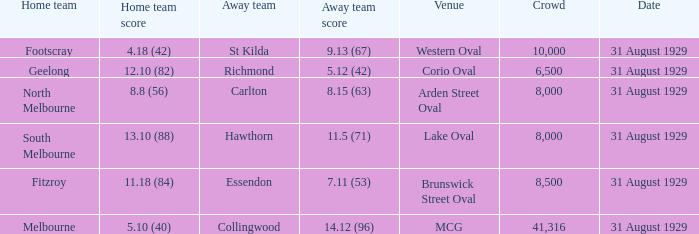What was the score of the home team when the away team scored 14.12 (96)? 5.10 (40). Help me parse the entirety of this table. {'header': ['Home team', 'Home team score', 'Away team', 'Away team score', 'Venue', 'Crowd', 'Date'], 'rows': [['Footscray', '4.18 (42)', 'St Kilda', '9.13 (67)', 'Western Oval', '10,000', '31 August 1929'], ['Geelong', '12.10 (82)', 'Richmond', '5.12 (42)', 'Corio Oval', '6,500', '31 August 1929'], ['North Melbourne', '8.8 (56)', 'Carlton', '8.15 (63)', 'Arden Street Oval', '8,000', '31 August 1929'], ['South Melbourne', '13.10 (88)', 'Hawthorn', '11.5 (71)', 'Lake Oval', '8,000', '31 August 1929'], ['Fitzroy', '11.18 (84)', 'Essendon', '7.11 (53)', 'Brunswick Street Oval', '8,500', '31 August 1929'], ['Melbourne', '5.10 (40)', 'Collingwood', '14.12 (96)', 'MCG', '41,316', '31 August 1929']]} 